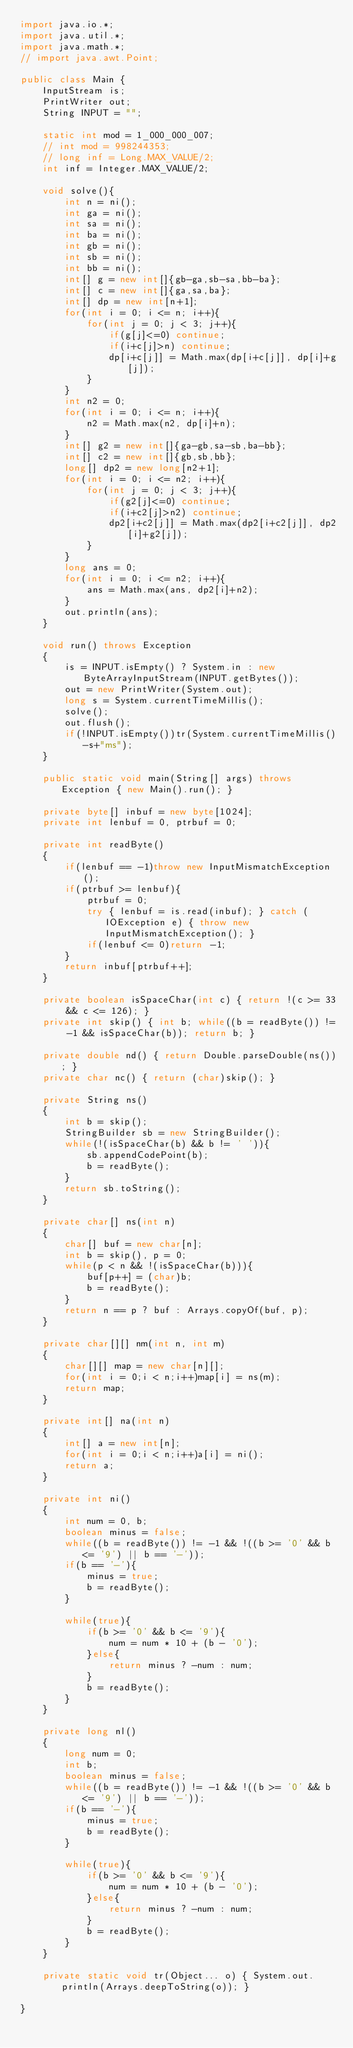Convert code to text. <code><loc_0><loc_0><loc_500><loc_500><_Java_>import java.io.*;
import java.util.*;
import java.math.*;
// import java.awt.Point;
 
public class Main {
    InputStream is;
    PrintWriter out;
    String INPUT = "";
 
    static int mod = 1_000_000_007;
    // int mod = 998244353;
    // long inf = Long.MAX_VALUE/2;
    int inf = Integer.MAX_VALUE/2;

    void solve(){
        int n = ni();
        int ga = ni();
        int sa = ni();
        int ba = ni();
        int gb = ni();
        int sb = ni();
        int bb = ni();
        int[] g = new int[]{gb-ga,sb-sa,bb-ba};
        int[] c = new int[]{ga,sa,ba};
        int[] dp = new int[n+1];
        for(int i = 0; i <= n; i++){
            for(int j = 0; j < 3; j++){
                if(g[j]<=0) continue;
                if(i+c[j]>n) continue;
                dp[i+c[j]] = Math.max(dp[i+c[j]], dp[i]+g[j]);
            }
        }
        int n2 = 0;
        for(int i = 0; i <= n; i++){
            n2 = Math.max(n2, dp[i]+n);
        }
        int[] g2 = new int[]{ga-gb,sa-sb,ba-bb};
        int[] c2 = new int[]{gb,sb,bb};
        long[] dp2 = new long[n2+1];
        for(int i = 0; i <= n2; i++){
            for(int j = 0; j < 3; j++){
                if(g2[j]<=0) continue;
                if(i+c2[j]>n2) continue;
                dp2[i+c2[j]] = Math.max(dp2[i+c2[j]], dp2[i]+g2[j]);
            }
        }
        long ans = 0;
        for(int i = 0; i <= n2; i++){
            ans = Math.max(ans, dp2[i]+n2);
        }
        out.println(ans);
    }

    void run() throws Exception
    {
        is = INPUT.isEmpty() ? System.in : new ByteArrayInputStream(INPUT.getBytes());
        out = new PrintWriter(System.out);
        long s = System.currentTimeMillis();
        solve();
        out.flush();
        if(!INPUT.isEmpty())tr(System.currentTimeMillis()-s+"ms");
    }
    
    public static void main(String[] args) throws Exception { new Main().run(); }
    
    private byte[] inbuf = new byte[1024];
    private int lenbuf = 0, ptrbuf = 0;
    
    private int readByte()
    {
        if(lenbuf == -1)throw new InputMismatchException();
        if(ptrbuf >= lenbuf){
            ptrbuf = 0;
            try { lenbuf = is.read(inbuf); } catch (IOException e) { throw new InputMismatchException(); }
            if(lenbuf <= 0)return -1;
        }
        return inbuf[ptrbuf++];
    }
    
    private boolean isSpaceChar(int c) { return !(c >= 33 && c <= 126); }
    private int skip() { int b; while((b = readByte()) != -1 && isSpaceChar(b)); return b; }
    
    private double nd() { return Double.parseDouble(ns()); }
    private char nc() { return (char)skip(); }
    
    private String ns()
    {
        int b = skip();
        StringBuilder sb = new StringBuilder();
        while(!(isSpaceChar(b) && b != ' ')){
            sb.appendCodePoint(b);
            b = readByte();
        }
        return sb.toString();
    }
    
    private char[] ns(int n)
    {
        char[] buf = new char[n];
        int b = skip(), p = 0;
        while(p < n && !(isSpaceChar(b))){
            buf[p++] = (char)b;
            b = readByte();
        }
        return n == p ? buf : Arrays.copyOf(buf, p);
    }
    
    private char[][] nm(int n, int m)
    {
        char[][] map = new char[n][];
        for(int i = 0;i < n;i++)map[i] = ns(m);
        return map;
    }
    
    private int[] na(int n)
    {
        int[] a = new int[n];
        for(int i = 0;i < n;i++)a[i] = ni();
        return a;
    }
    
    private int ni()
    {
        int num = 0, b;
        boolean minus = false;
        while((b = readByte()) != -1 && !((b >= '0' && b <= '9') || b == '-'));
        if(b == '-'){
            minus = true;
            b = readByte();
        }
        
        while(true){
            if(b >= '0' && b <= '9'){
                num = num * 10 + (b - '0');
            }else{
                return minus ? -num : num;
            }
            b = readByte();
        }
    }
    
    private long nl()
    {
        long num = 0;
        int b;
        boolean minus = false;
        while((b = readByte()) != -1 && !((b >= '0' && b <= '9') || b == '-'));
        if(b == '-'){
            minus = true;
            b = readByte();
        }
        
        while(true){
            if(b >= '0' && b <= '9'){
                num = num * 10 + (b - '0');
            }else{
                return minus ? -num : num;
            }
            b = readByte();
        }
    }
    
    private static void tr(Object... o) { System.out.println(Arrays.deepToString(o)); }
 
}
</code> 